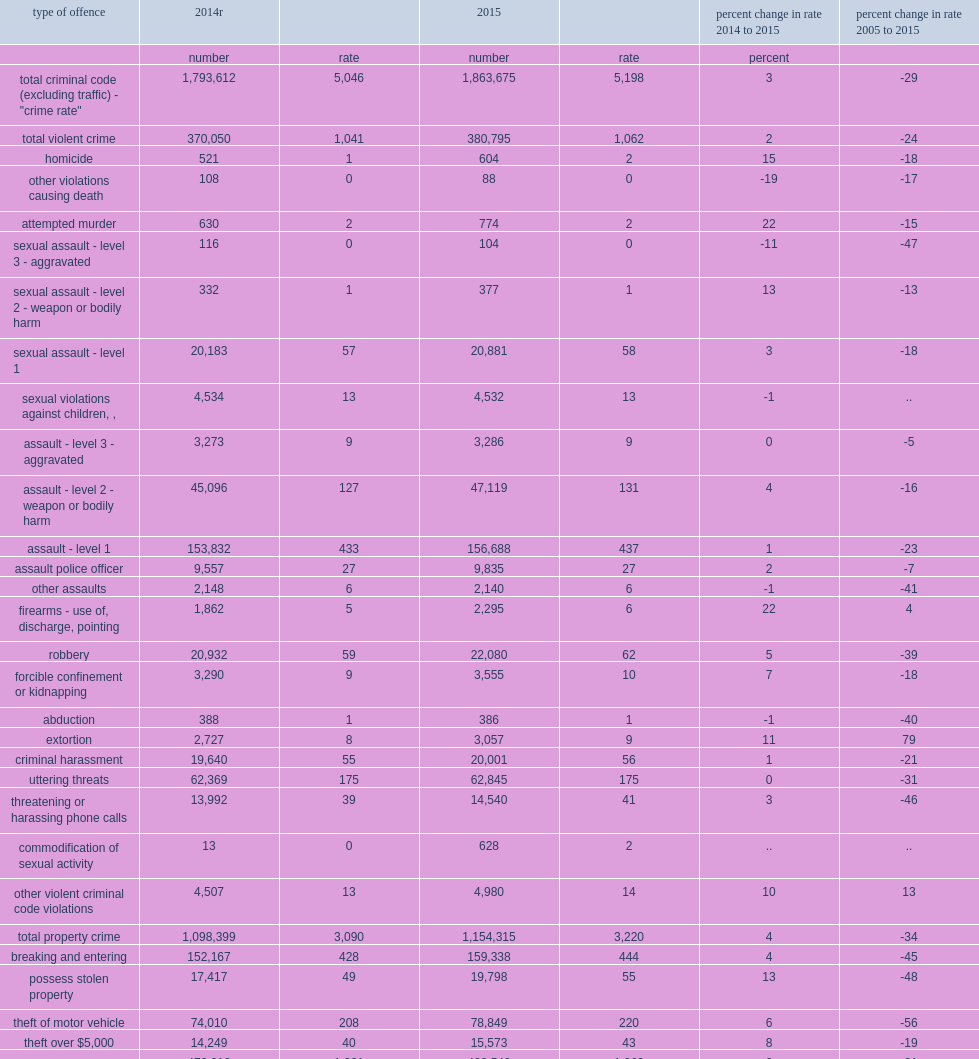What is the percentage of the most notable increases were for homicide from 2014 to 2015? 15.0. In addition,what is the rates of extortion also notably higher than the previous year? 11.0. In addition,what is the rates of sexual assault with a weapon or bodily harm (level 2) also notably higher than the previous year? 13.0. What is the percentage of the violent offences for which rates decreased in 2015 were other violations causing death (which includes criminal negligence)? 19. Other categories of assault include assault with a weapon or causing bodily harm (level 2),what is the percentage of the increase of it from 2014 to 2015? 4.0. Between 2014 and 2015,what is the rate of sexual assault level 1 increased ? 3.0. What is the rates of sexual assault level 2 also increased with a total of 377 incidents reported in 2015? 13.0. In contrast, what is the rate of the most serious sexual assaults (level 3) declined in 2015 with 104 incidents (12 fewer than in 2014) ? 11. Other offences which reported large increases, but with less impact on the non-violent csi, included possession of stolen property, what is the percentage of its increase? 13.0. In 2015, there were about 96,000 cdsa offences reported by police, what is the rate of it? 269.0. 